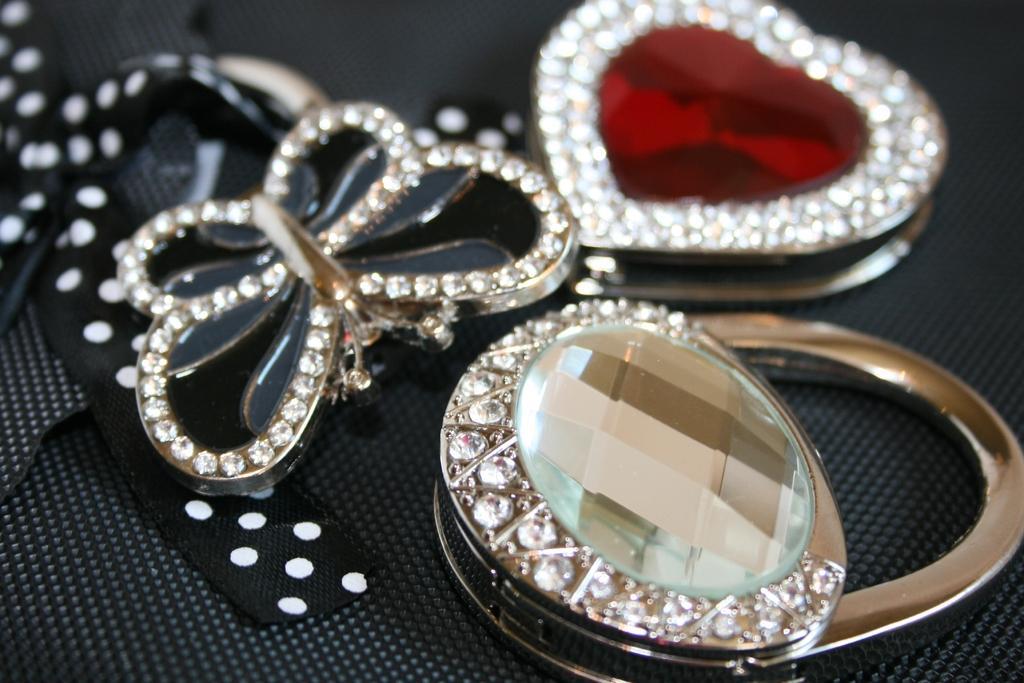Could you give a brief overview of what you see in this image? In this picture we can see three pendants on a platform. 